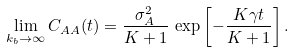Convert formula to latex. <formula><loc_0><loc_0><loc_500><loc_500>\lim _ { k _ { b } \to \infty } C _ { A A } ( t ) = \frac { \sigma _ { A } ^ { 2 } } { K + 1 } \, \exp \left [ - \frac { K \gamma t } { K + 1 } \right ] .</formula> 